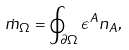Convert formula to latex. <formula><loc_0><loc_0><loc_500><loc_500>\dot { m } _ { \Omega } = \oint _ { \partial \Omega } \epsilon ^ { A } n _ { A } ,</formula> 